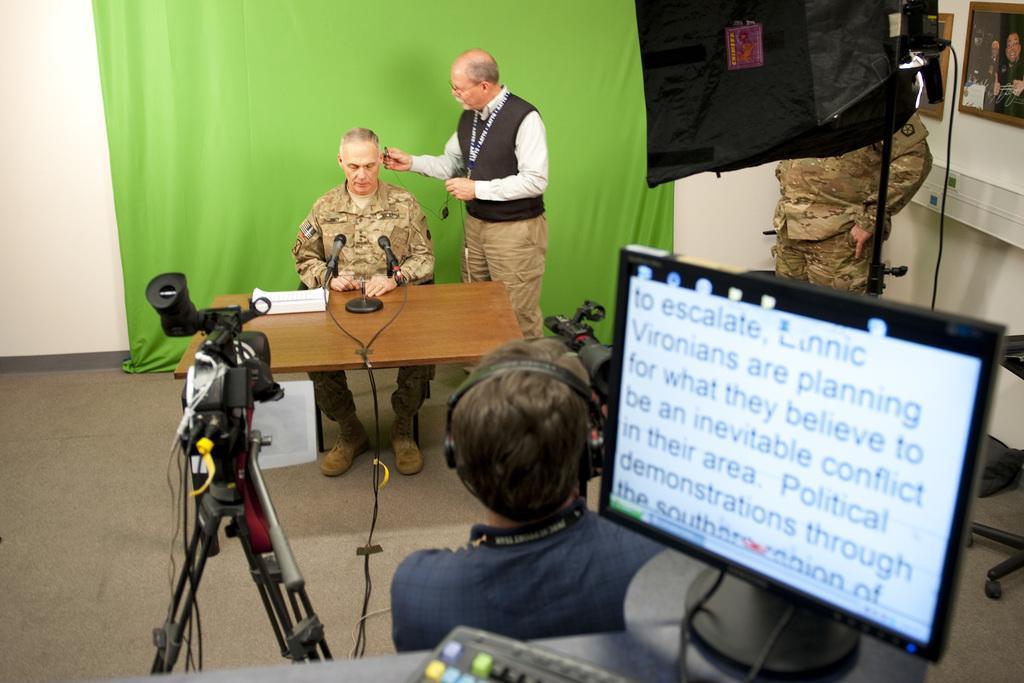Can you describe this image briefly? There are three persons. He is sitting on the chair and he is holding a camera. There is a carpet on the floor. This is a table. On the table there is a book, and mike's. Here we can see a monitor, keyboard, and a cloth. In the background there is a wall and frames. 